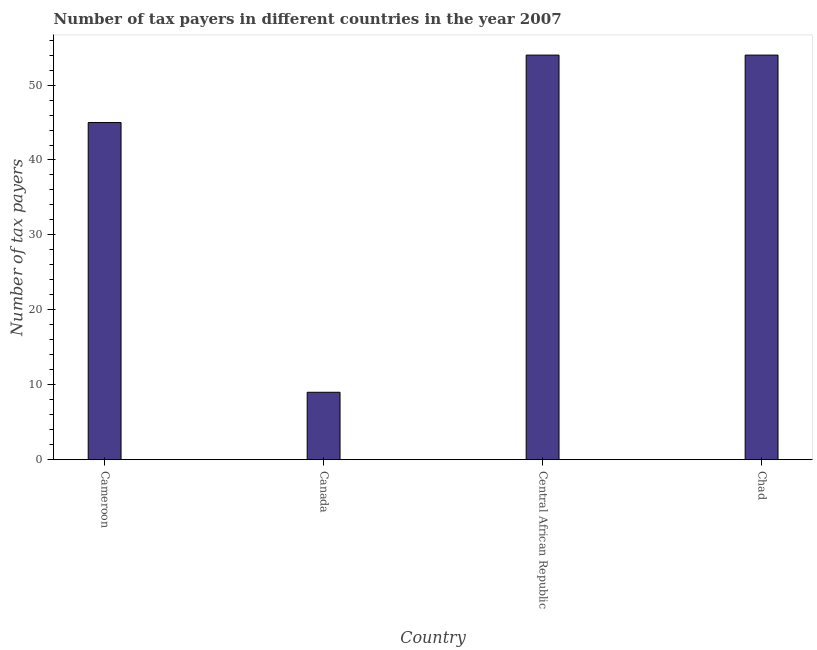What is the title of the graph?
Your response must be concise. Number of tax payers in different countries in the year 2007. What is the label or title of the X-axis?
Provide a succinct answer. Country. What is the label or title of the Y-axis?
Provide a succinct answer. Number of tax payers. Across all countries, what is the minimum number of tax payers?
Give a very brief answer. 9. In which country was the number of tax payers maximum?
Your response must be concise. Central African Republic. In which country was the number of tax payers minimum?
Provide a short and direct response. Canada. What is the sum of the number of tax payers?
Make the answer very short. 162. What is the difference between the number of tax payers in Cameroon and Central African Republic?
Provide a succinct answer. -9. What is the average number of tax payers per country?
Your answer should be compact. 40.5. What is the median number of tax payers?
Provide a short and direct response. 49.5. What is the ratio of the number of tax payers in Cameroon to that in Chad?
Your response must be concise. 0.83. Is the number of tax payers in Cameroon less than that in Central African Republic?
Your answer should be compact. Yes. What is the difference between the highest and the second highest number of tax payers?
Your answer should be compact. 0. Is the sum of the number of tax payers in Cameroon and Canada greater than the maximum number of tax payers across all countries?
Give a very brief answer. No. Are the values on the major ticks of Y-axis written in scientific E-notation?
Offer a very short reply. No. What is the Number of tax payers in Cameroon?
Your answer should be compact. 45. What is the Number of tax payers in Canada?
Offer a very short reply. 9. What is the Number of tax payers of Central African Republic?
Make the answer very short. 54. What is the Number of tax payers of Chad?
Provide a short and direct response. 54. What is the difference between the Number of tax payers in Cameroon and Canada?
Offer a very short reply. 36. What is the difference between the Number of tax payers in Cameroon and Chad?
Give a very brief answer. -9. What is the difference between the Number of tax payers in Canada and Central African Republic?
Offer a terse response. -45. What is the difference between the Number of tax payers in Canada and Chad?
Give a very brief answer. -45. What is the ratio of the Number of tax payers in Cameroon to that in Central African Republic?
Offer a terse response. 0.83. What is the ratio of the Number of tax payers in Cameroon to that in Chad?
Your response must be concise. 0.83. What is the ratio of the Number of tax payers in Canada to that in Central African Republic?
Your answer should be very brief. 0.17. What is the ratio of the Number of tax payers in Canada to that in Chad?
Make the answer very short. 0.17. What is the ratio of the Number of tax payers in Central African Republic to that in Chad?
Your answer should be compact. 1. 